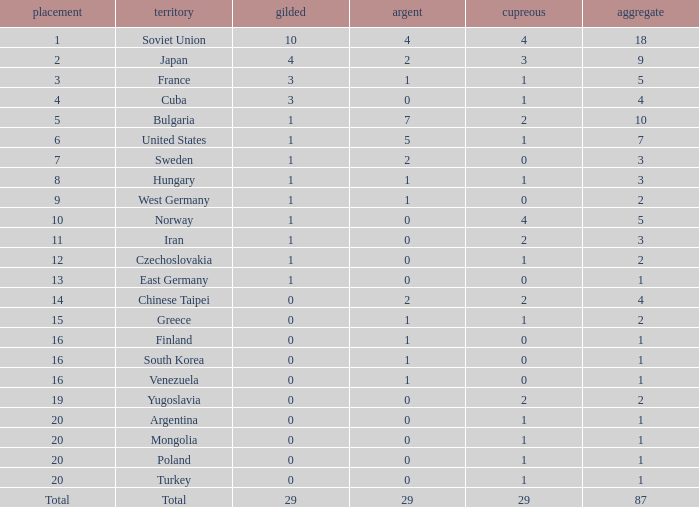What is the sum of gold medals for a rank of 14? 0.0. 